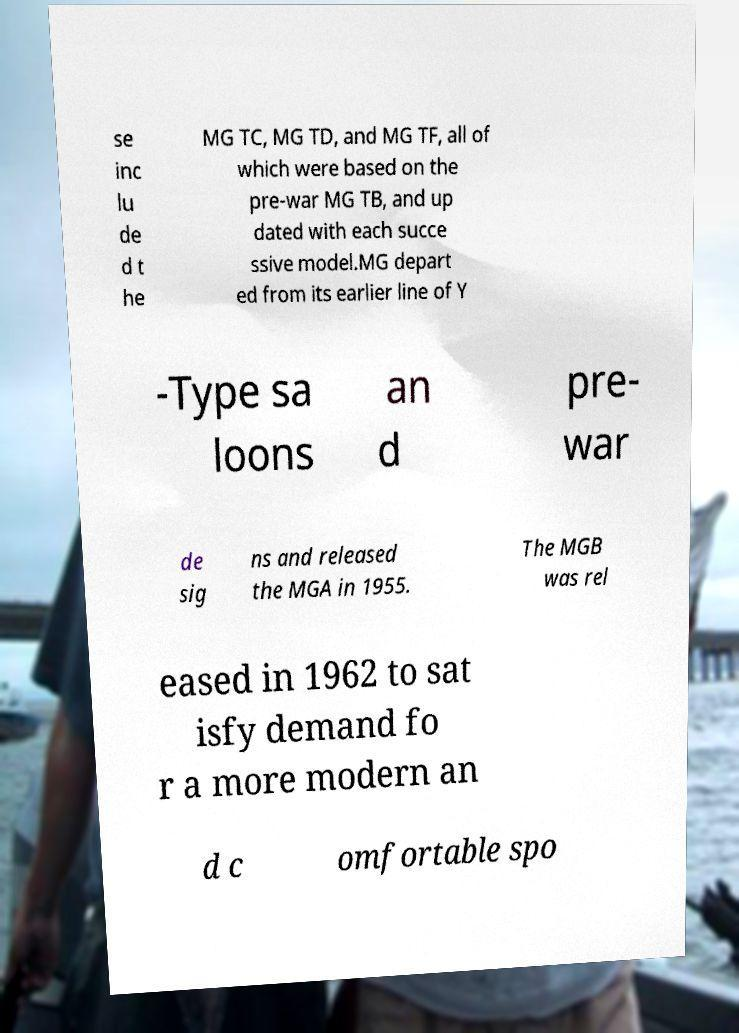I need the written content from this picture converted into text. Can you do that? se inc lu de d t he MG TC, MG TD, and MG TF, all of which were based on the pre-war MG TB, and up dated with each succe ssive model.MG depart ed from its earlier line of Y -Type sa loons an d pre- war de sig ns and released the MGA in 1955. The MGB was rel eased in 1962 to sat isfy demand fo r a more modern an d c omfortable spo 